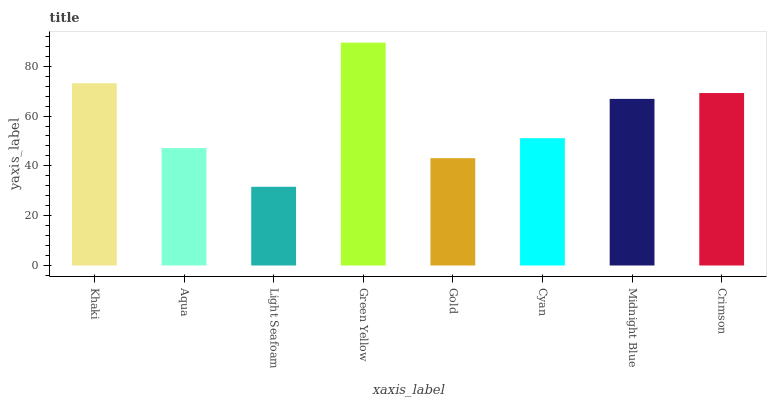Is Light Seafoam the minimum?
Answer yes or no. Yes. Is Green Yellow the maximum?
Answer yes or no. Yes. Is Aqua the minimum?
Answer yes or no. No. Is Aqua the maximum?
Answer yes or no. No. Is Khaki greater than Aqua?
Answer yes or no. Yes. Is Aqua less than Khaki?
Answer yes or no. Yes. Is Aqua greater than Khaki?
Answer yes or no. No. Is Khaki less than Aqua?
Answer yes or no. No. Is Midnight Blue the high median?
Answer yes or no. Yes. Is Cyan the low median?
Answer yes or no. Yes. Is Cyan the high median?
Answer yes or no. No. Is Midnight Blue the low median?
Answer yes or no. No. 